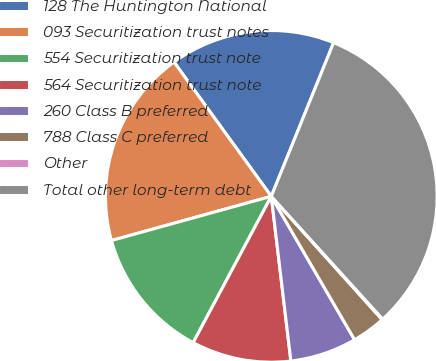Convert chart. <chart><loc_0><loc_0><loc_500><loc_500><pie_chart><fcel>128 The Huntington National<fcel>093 Securitization trust notes<fcel>554 Securitization trust note<fcel>564 Securitization trust note<fcel>260 Class B preferred<fcel>788 Class C preferred<fcel>Other<fcel>Total other long-term debt<nl><fcel>16.11%<fcel>19.31%<fcel>12.9%<fcel>9.69%<fcel>6.49%<fcel>3.28%<fcel>0.07%<fcel>32.14%<nl></chart> 